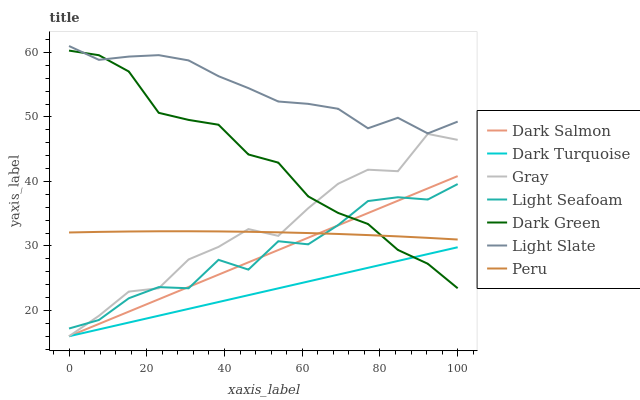Does Dark Turquoise have the minimum area under the curve?
Answer yes or no. Yes. Does Light Slate have the maximum area under the curve?
Answer yes or no. Yes. Does Light Slate have the minimum area under the curve?
Answer yes or no. No. Does Dark Turquoise have the maximum area under the curve?
Answer yes or no. No. Is Dark Turquoise the smoothest?
Answer yes or no. Yes. Is Light Seafoam the roughest?
Answer yes or no. Yes. Is Light Slate the smoothest?
Answer yes or no. No. Is Light Slate the roughest?
Answer yes or no. No. Does Gray have the lowest value?
Answer yes or no. Yes. Does Light Slate have the lowest value?
Answer yes or no. No. Does Light Slate have the highest value?
Answer yes or no. Yes. Does Dark Turquoise have the highest value?
Answer yes or no. No. Is Gray less than Light Slate?
Answer yes or no. Yes. Is Peru greater than Dark Turquoise?
Answer yes or no. Yes. Does Dark Salmon intersect Gray?
Answer yes or no. Yes. Is Dark Salmon less than Gray?
Answer yes or no. No. Is Dark Salmon greater than Gray?
Answer yes or no. No. Does Gray intersect Light Slate?
Answer yes or no. No. 